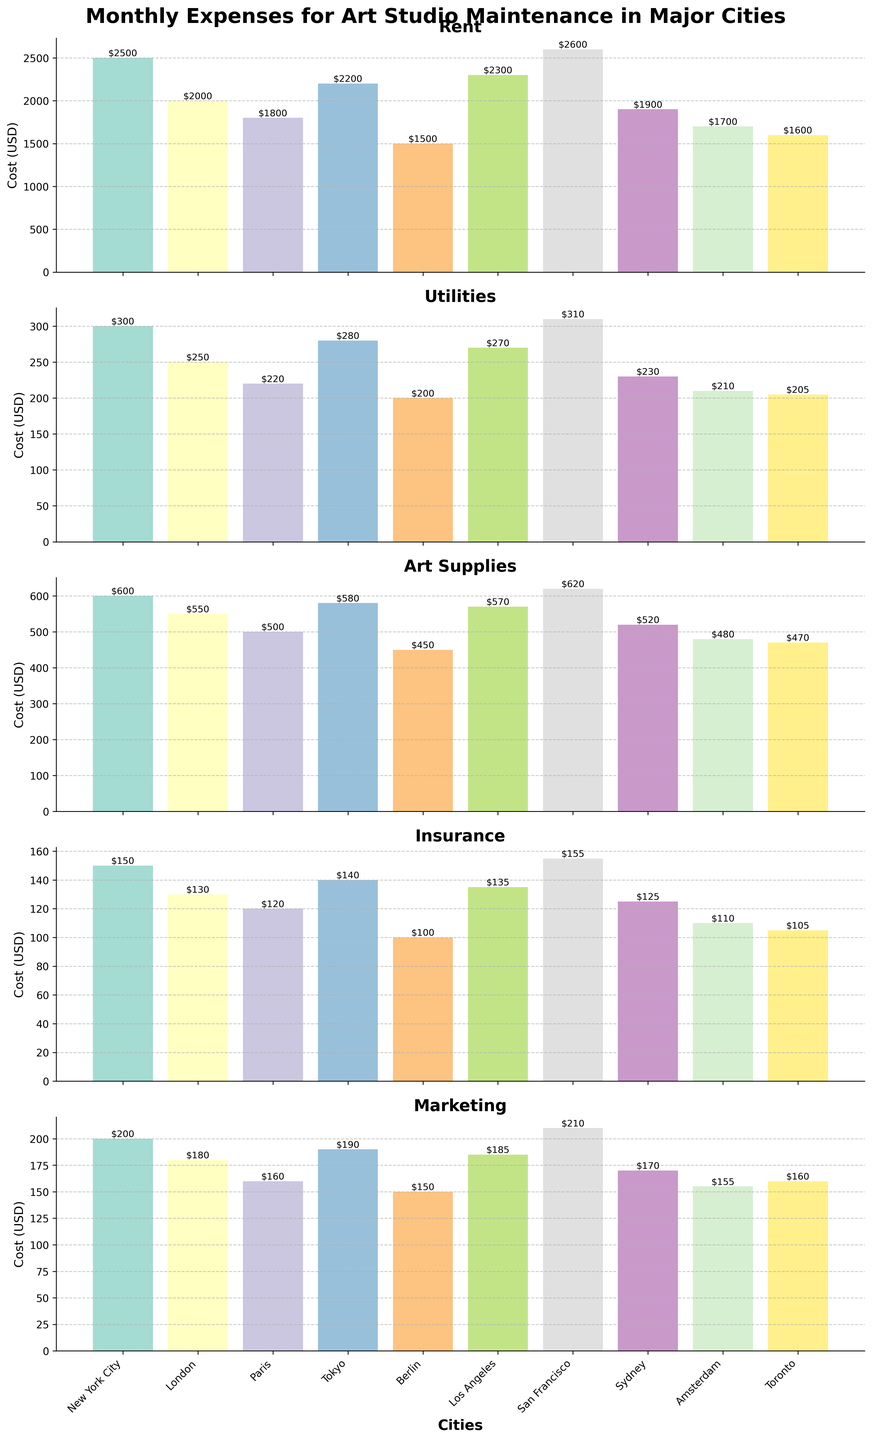What is the title of the figure? The title of the figure can be found at the top, summarizing the content of the entire visual. It reads "Monthly Expenses for Art Studio Maintenance in Major Cities" in bold and large font.
Answer: Monthly Expenses for Art Studio Maintenance in Major Cities What is the highest expense for an art studio in New York City? To find this, look under the New York City bar in each subplot and identify the highest value. Rent is the tallest bar for New York City.
Answer: Rent Which city has the lowest utility costs? By examining the Utilities subplot, the city with the shortest bar will indicate the lowest utility costs. This is Berlin.
Answer: Berlin Compare the rent costs between San Francisco and London. Which city has higher rent? In the Rent subplot, visually compare the heights of the bars for San Francisco and London. San Francisco's bar is taller.
Answer: San Francisco What is the total monthly expense for utilities in all cities combined? Sum the utility costs for each city: 300 (NYC) + 250 (London) + 220 (Paris) + 280 (Tokyo) + 200 (Berlin) + 270 (LA) + 310 (SF) + 230 (Sydney) + 210 (Amsterdam) + 205 (Toronto) = 2,475
Answer: 2,475 Which city has the highest marketing expense? In the Marketing subplot, identify the city with the tallest bar. San Francisco has the tallest bar.
Answer: San Francisco For Tokyo, how much more is the rent compared to utilities? Find the bar heights for Rent and Utilities in Tokyo. Rent is 2200 and Utilities are 280. 2200 - 280 = 1920
Answer: 1920 What is the average cost of art supplies across all cities? Sum the art supplies costs and divide by the number of cities: (600 + 550 + 500 + 580 + 450 + 570 + 620 + 520 + 480 + 470) / 10 = 5,340 / 10 = 534
Answer: 534 Which city has the lowest rent? In the Rent subplot, identify the city with the shortest bar. Berlin has the lowest rent.
Answer: Berlin Compare the total costs for maintaining an art studio in New York City and Berlin. Which one is higher and by how much? Sum up all expenses for New York City and Berlin, then compare. NYC total: 2500 + 300 + 600 + 150 + 200 = 3750; Berlin total: 1500 + 200 + 450 + 100 + 150 = 2400; Difference: 3750 - 2400 = 1350.
Answer: New York City by 1350 